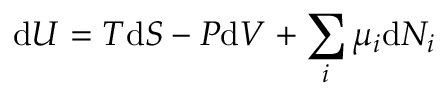Convert formula to latex. <formula><loc_0><loc_0><loc_500><loc_500>d U = T d S - P d V + \sum _ { i } \mu _ { i } d N _ { i } \,</formula> 